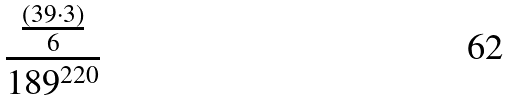Convert formula to latex. <formula><loc_0><loc_0><loc_500><loc_500>\frac { \frac { ( 3 9 \cdot 3 ) } { 6 } } { 1 8 9 ^ { 2 2 0 } }</formula> 